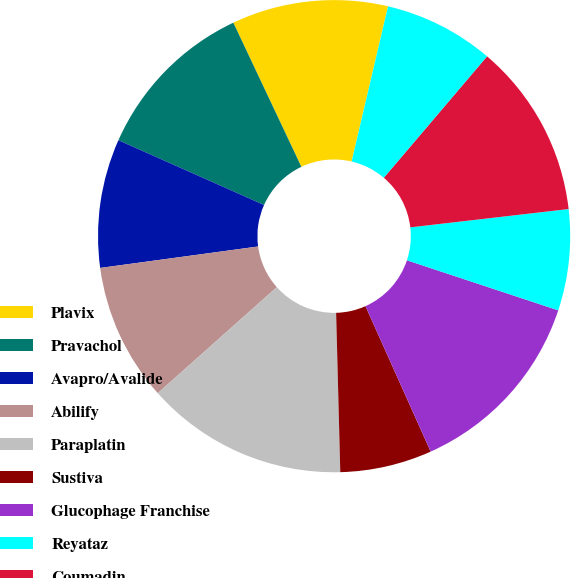<chart> <loc_0><loc_0><loc_500><loc_500><pie_chart><fcel>Plavix<fcel>Pravachol<fcel>Avapro/Avalide<fcel>Abilify<fcel>Paraplatin<fcel>Sustiva<fcel>Glucophage Franchise<fcel>Reyataz<fcel>Coumadin<fcel>Tequin<nl><fcel>10.69%<fcel>11.32%<fcel>8.81%<fcel>9.43%<fcel>13.84%<fcel>6.29%<fcel>13.21%<fcel>6.92%<fcel>11.95%<fcel>7.55%<nl></chart> 